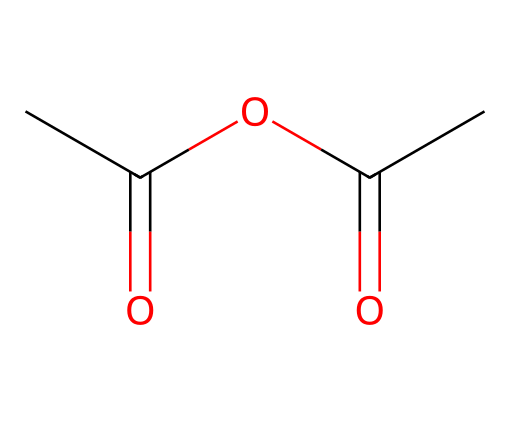What is the systematic name of this compound? This compound consists of two acetyl groups connected by an oxygen atom. The systematic name of this structure is derived from its functional groups. The common name "acetic anhydride" reflects that it is an anhydride of acetic acid.
Answer: acetic anhydride How many carbon atoms are present in this molecule? By analyzing the SMILES representation, we can count the number of carbon atoms (C). There are four carbon atoms indicated in the structure: two from each acetic acid moiety.
Answer: four What is the total number of oxygen atoms in the structure? The SMILES indicates that there are two carbonyl (C=O) groups and one ether (C-O-C) link, totaling three oxygen atoms connected: two in carbonyls and one in the ether.
Answer: three What bond type is present between the carbon and oxygen atoms in the carbonyl groups? The bonds between carbon and oxygen in the carbonyl functional groups are characteristic of double bonds, as shown in their structure of C=O.
Answer: double Which functional group characterizes this compound as an acid anhydride? The presence of two acyl groups connected by an oxygen atom is the defining feature of acid anhydrides. In this case, it's the acyl from acetic acid that makes it an anhydride.
Answer: acyl group What is the molecular formula of acetic anhydride? To deduce the molecular formula, we count the atoms in the structure: C4 (four carbon atoms), H6 (six hydrogen atoms), and O3 (three oxygen atoms), leading to the formula C4H6O3.
Answer: C4H6O3 